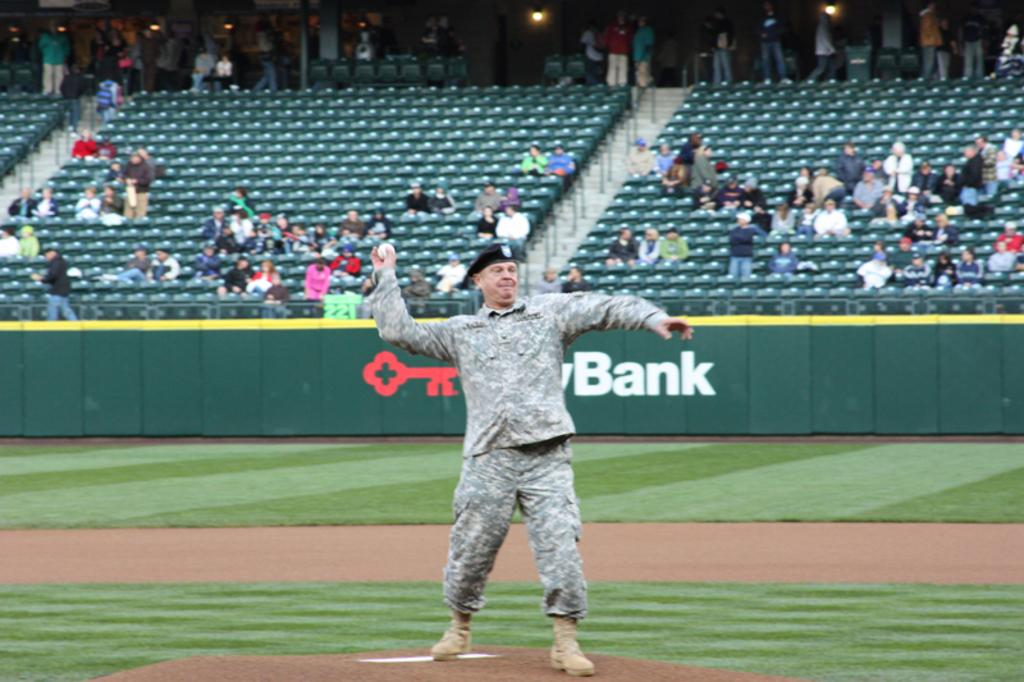Provide a one-sentence caption for the provided image. US Army Soldier throwing the first pitch at a baseball game, with a key bank logo in the background. 